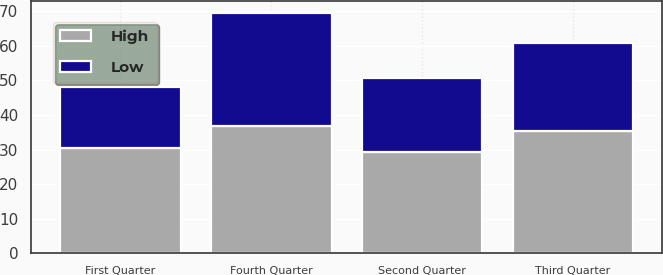Convert chart to OTSL. <chart><loc_0><loc_0><loc_500><loc_500><stacked_bar_chart><ecel><fcel>First Quarter<fcel>Second Quarter<fcel>Third Quarter<fcel>Fourth Quarter<nl><fcel>High<fcel>30.6<fcel>29.17<fcel>35.49<fcel>36.84<nl><fcel>Low<fcel>17.4<fcel>21.49<fcel>25.27<fcel>32.77<nl></chart> 